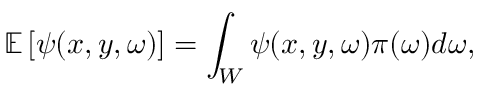Convert formula to latex. <formula><loc_0><loc_0><loc_500><loc_500>\mathbb { E } \left [ \psi ( x , y , \boldsymbol \omega ) \right ] = \int _ { W } \psi ( x , y , \omega ) \pi ( \boldsymbol \omega ) d \omega ,</formula> 